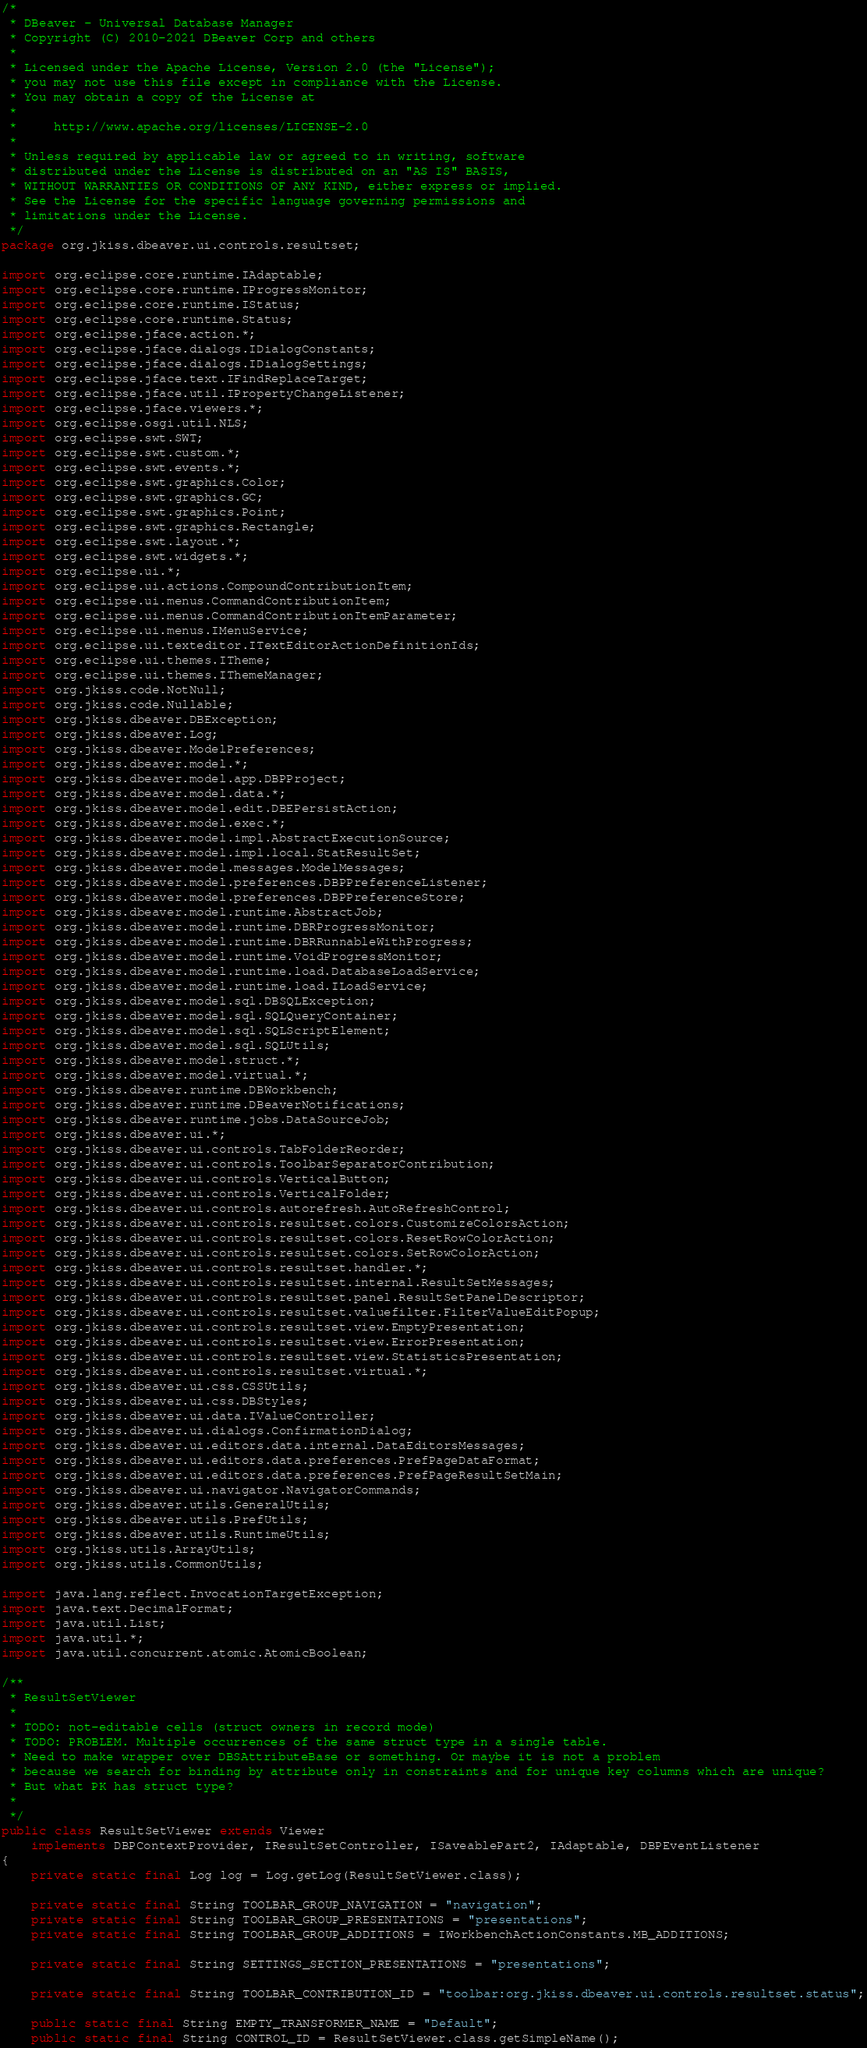<code> <loc_0><loc_0><loc_500><loc_500><_Java_>/*
 * DBeaver - Universal Database Manager
 * Copyright (C) 2010-2021 DBeaver Corp and others
 *
 * Licensed under the Apache License, Version 2.0 (the "License");
 * you may not use this file except in compliance with the License.
 * You may obtain a copy of the License at
 *
 *     http://www.apache.org/licenses/LICENSE-2.0
 *
 * Unless required by applicable law or agreed to in writing, software
 * distributed under the License is distributed on an "AS IS" BASIS,
 * WITHOUT WARRANTIES OR CONDITIONS OF ANY KIND, either express or implied.
 * See the License for the specific language governing permissions and
 * limitations under the License.
 */
package org.jkiss.dbeaver.ui.controls.resultset;

import org.eclipse.core.runtime.IAdaptable;
import org.eclipse.core.runtime.IProgressMonitor;
import org.eclipse.core.runtime.IStatus;
import org.eclipse.core.runtime.Status;
import org.eclipse.jface.action.*;
import org.eclipse.jface.dialogs.IDialogConstants;
import org.eclipse.jface.dialogs.IDialogSettings;
import org.eclipse.jface.text.IFindReplaceTarget;
import org.eclipse.jface.util.IPropertyChangeListener;
import org.eclipse.jface.viewers.*;
import org.eclipse.osgi.util.NLS;
import org.eclipse.swt.SWT;
import org.eclipse.swt.custom.*;
import org.eclipse.swt.events.*;
import org.eclipse.swt.graphics.Color;
import org.eclipse.swt.graphics.GC;
import org.eclipse.swt.graphics.Point;
import org.eclipse.swt.graphics.Rectangle;
import org.eclipse.swt.layout.*;
import org.eclipse.swt.widgets.*;
import org.eclipse.ui.*;
import org.eclipse.ui.actions.CompoundContributionItem;
import org.eclipse.ui.menus.CommandContributionItem;
import org.eclipse.ui.menus.CommandContributionItemParameter;
import org.eclipse.ui.menus.IMenuService;
import org.eclipse.ui.texteditor.ITextEditorActionDefinitionIds;
import org.eclipse.ui.themes.ITheme;
import org.eclipse.ui.themes.IThemeManager;
import org.jkiss.code.NotNull;
import org.jkiss.code.Nullable;
import org.jkiss.dbeaver.DBException;
import org.jkiss.dbeaver.Log;
import org.jkiss.dbeaver.ModelPreferences;
import org.jkiss.dbeaver.model.*;
import org.jkiss.dbeaver.model.app.DBPProject;
import org.jkiss.dbeaver.model.data.*;
import org.jkiss.dbeaver.model.edit.DBEPersistAction;
import org.jkiss.dbeaver.model.exec.*;
import org.jkiss.dbeaver.model.impl.AbstractExecutionSource;
import org.jkiss.dbeaver.model.impl.local.StatResultSet;
import org.jkiss.dbeaver.model.messages.ModelMessages;
import org.jkiss.dbeaver.model.preferences.DBPPreferenceListener;
import org.jkiss.dbeaver.model.preferences.DBPPreferenceStore;
import org.jkiss.dbeaver.model.runtime.AbstractJob;
import org.jkiss.dbeaver.model.runtime.DBRProgressMonitor;
import org.jkiss.dbeaver.model.runtime.DBRRunnableWithProgress;
import org.jkiss.dbeaver.model.runtime.VoidProgressMonitor;
import org.jkiss.dbeaver.model.runtime.load.DatabaseLoadService;
import org.jkiss.dbeaver.model.runtime.load.ILoadService;
import org.jkiss.dbeaver.model.sql.DBSQLException;
import org.jkiss.dbeaver.model.sql.SQLQueryContainer;
import org.jkiss.dbeaver.model.sql.SQLScriptElement;
import org.jkiss.dbeaver.model.sql.SQLUtils;
import org.jkiss.dbeaver.model.struct.*;
import org.jkiss.dbeaver.model.virtual.*;
import org.jkiss.dbeaver.runtime.DBWorkbench;
import org.jkiss.dbeaver.runtime.DBeaverNotifications;
import org.jkiss.dbeaver.runtime.jobs.DataSourceJob;
import org.jkiss.dbeaver.ui.*;
import org.jkiss.dbeaver.ui.controls.TabFolderReorder;
import org.jkiss.dbeaver.ui.controls.ToolbarSeparatorContribution;
import org.jkiss.dbeaver.ui.controls.VerticalButton;
import org.jkiss.dbeaver.ui.controls.VerticalFolder;
import org.jkiss.dbeaver.ui.controls.autorefresh.AutoRefreshControl;
import org.jkiss.dbeaver.ui.controls.resultset.colors.CustomizeColorsAction;
import org.jkiss.dbeaver.ui.controls.resultset.colors.ResetRowColorAction;
import org.jkiss.dbeaver.ui.controls.resultset.colors.SetRowColorAction;
import org.jkiss.dbeaver.ui.controls.resultset.handler.*;
import org.jkiss.dbeaver.ui.controls.resultset.internal.ResultSetMessages;
import org.jkiss.dbeaver.ui.controls.resultset.panel.ResultSetPanelDescriptor;
import org.jkiss.dbeaver.ui.controls.resultset.valuefilter.FilterValueEditPopup;
import org.jkiss.dbeaver.ui.controls.resultset.view.EmptyPresentation;
import org.jkiss.dbeaver.ui.controls.resultset.view.ErrorPresentation;
import org.jkiss.dbeaver.ui.controls.resultset.view.StatisticsPresentation;
import org.jkiss.dbeaver.ui.controls.resultset.virtual.*;
import org.jkiss.dbeaver.ui.css.CSSUtils;
import org.jkiss.dbeaver.ui.css.DBStyles;
import org.jkiss.dbeaver.ui.data.IValueController;
import org.jkiss.dbeaver.ui.dialogs.ConfirmationDialog;
import org.jkiss.dbeaver.ui.editors.data.internal.DataEditorsMessages;
import org.jkiss.dbeaver.ui.editors.data.preferences.PrefPageDataFormat;
import org.jkiss.dbeaver.ui.editors.data.preferences.PrefPageResultSetMain;
import org.jkiss.dbeaver.ui.navigator.NavigatorCommands;
import org.jkiss.dbeaver.utils.GeneralUtils;
import org.jkiss.dbeaver.utils.PrefUtils;
import org.jkiss.dbeaver.utils.RuntimeUtils;
import org.jkiss.utils.ArrayUtils;
import org.jkiss.utils.CommonUtils;

import java.lang.reflect.InvocationTargetException;
import java.text.DecimalFormat;
import java.util.List;
import java.util.*;
import java.util.concurrent.atomic.AtomicBoolean;

/**
 * ResultSetViewer
 *
 * TODO: not-editable cells (struct owners in record mode)
 * TODO: PROBLEM. Multiple occurrences of the same struct type in a single table.
 * Need to make wrapper over DBSAttributeBase or something. Or maybe it is not a problem
 * because we search for binding by attribute only in constraints and for unique key columns which are unique?
 * But what PK has struct type?
 *
 */
public class ResultSetViewer extends Viewer
    implements DBPContextProvider, IResultSetController, ISaveablePart2, IAdaptable, DBPEventListener
{
    private static final Log log = Log.getLog(ResultSetViewer.class);

    private static final String TOOLBAR_GROUP_NAVIGATION = "navigation";
    private static final String TOOLBAR_GROUP_PRESENTATIONS = "presentations";
    private static final String TOOLBAR_GROUP_ADDITIONS = IWorkbenchActionConstants.MB_ADDITIONS;

    private static final String SETTINGS_SECTION_PRESENTATIONS = "presentations";

    private static final String TOOLBAR_CONTRIBUTION_ID = "toolbar:org.jkiss.dbeaver.ui.controls.resultset.status";

    public static final String EMPTY_TRANSFORMER_NAME = "Default";
    public static final String CONTROL_ID = ResultSetViewer.class.getSimpleName();</code> 